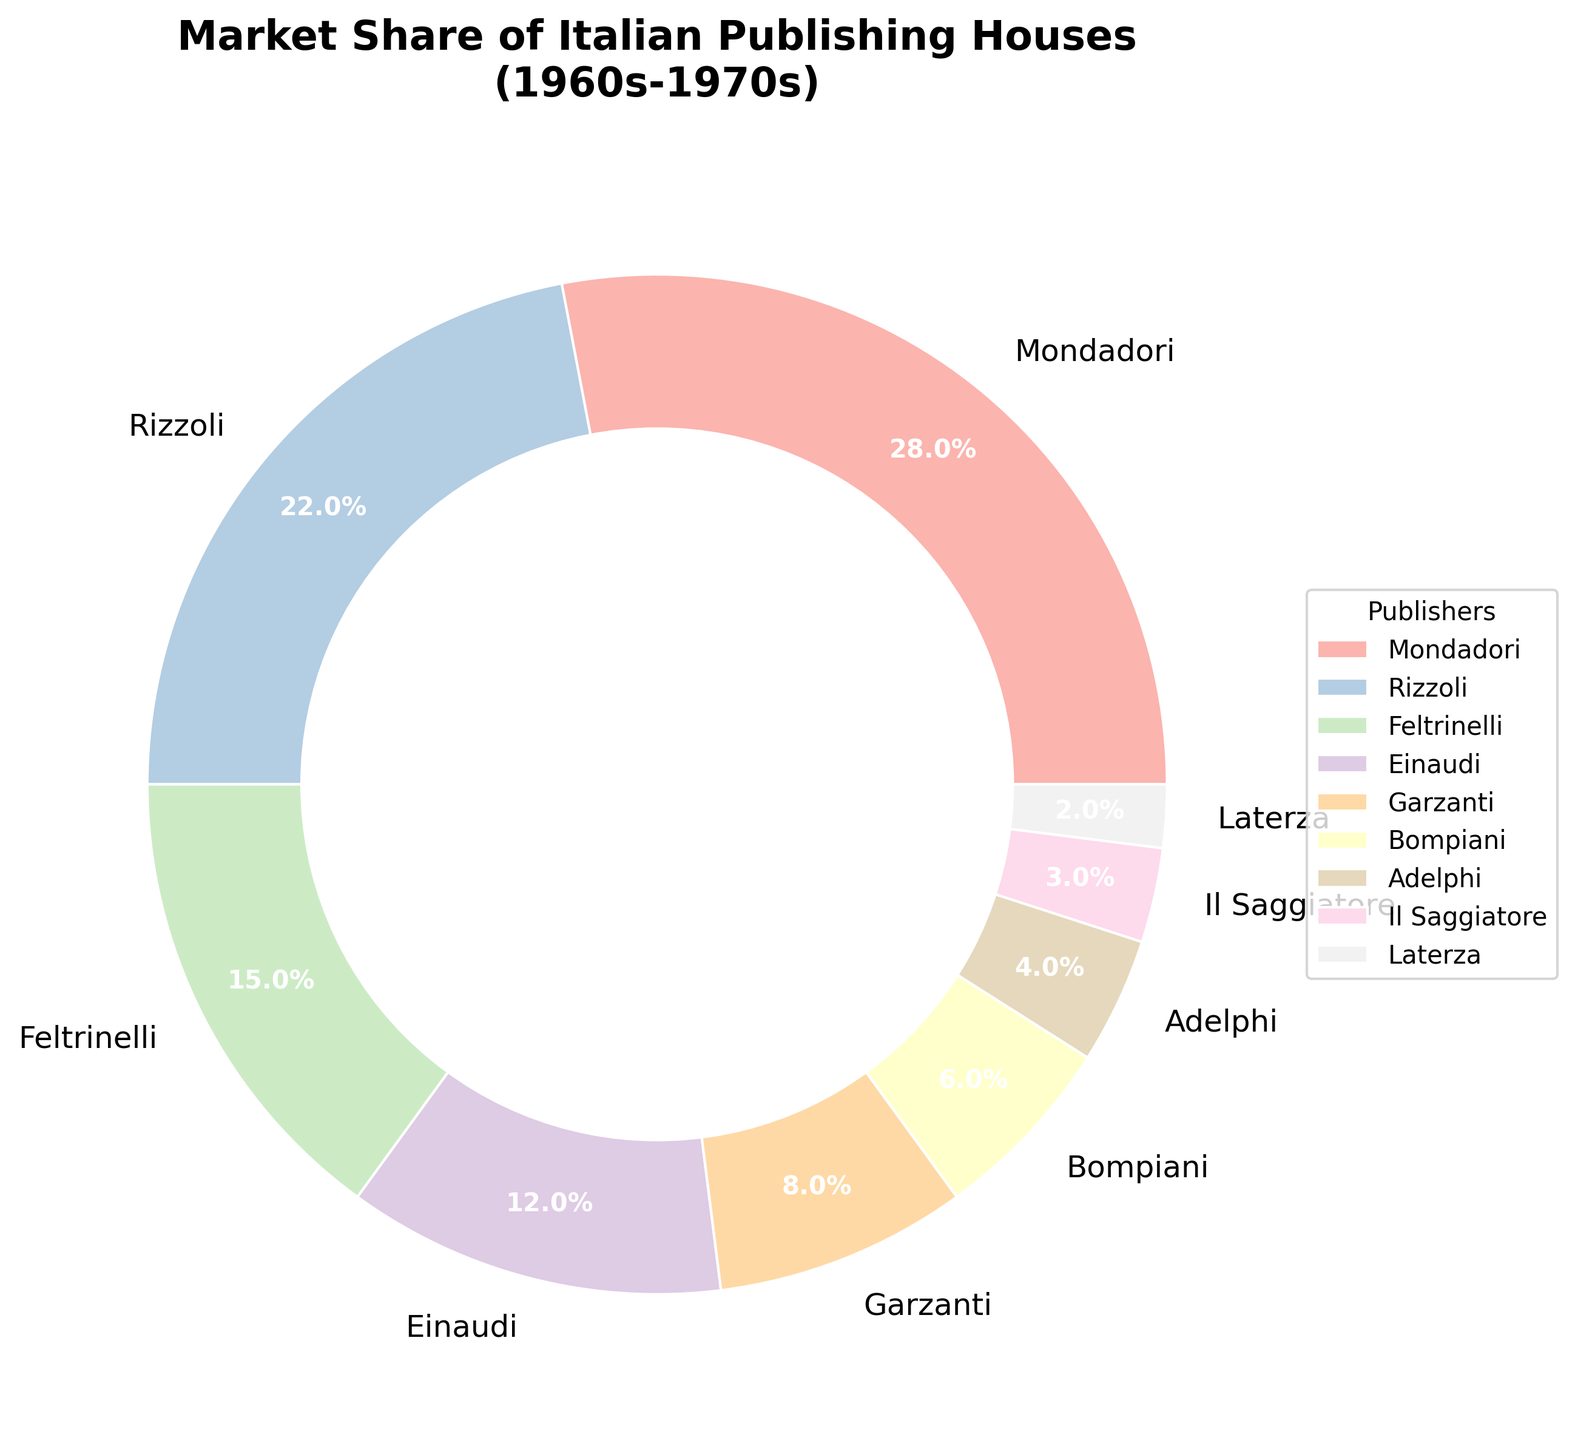Which publisher has the highest market share? The pie chart shows different sections representing each publisher's market share. The largest section corresponds to Mondadori with a market share of 28%.
Answer: Mondadori Which two publishers have market shares closest to each other? By comparing the market shares visually, Garzanti and Bompiani have market shares of 8% and 6%, respectively. These two values are closer to each other than any other pair of market shares.
Answer: Garzanti and Bompiani What is the combined market share of the three smallest publishers? The three smallest publishers are Il Saggiatore (3%), Laterza (2%), and Adelphi (4%). Adding these values: 3% + 2% + 4% = 9%.
Answer: 9% What percentage of the market does the top two publishers cover together? The top two publishers are Mondadori (28%) and Rizzoli (22%). Summing their market shares: 28% + 22% = 50%.
Answer: 50% By what percentage does Mondadori's market share exceed Einaudi's? Mondadori's market share is 28%, and Einaudi's is 12%. The difference is 28% - 12% = 16%. Therefore, Mondadori's market share exceeds Einaudi's by 16%.
Answer: 16% Which publisher is ranked fourth in terms of market share? The pie chart shows market shares in descending order. The fourth largest section corresponds to Einaudi with a market share of 12%.
Answer: Einaudi What is the difference in market share between the highest and lowest publishers? Mondadori has the highest market share at 28% and Laterza has the lowest at 2%. The difference is 28% - 2% = 26%.
Answer: 26% Which color is used to represent Feltrinelli? By examining the color legend and matching the corresponding section of the pie chart, the color representing Feltrinelli is found.
Answer: (Answer requires visual inspection and inference, not provided directly from data) Is the market share of Rizzoli more or less than double that of Garzanti? Rizzoli's market share is 22%, and Garzanti's is 8%. Double of Garzanti's market share is 16%. Since 22% > 16%, Rizzoli's market share is more than double that of Garzanti.
Answer: More 